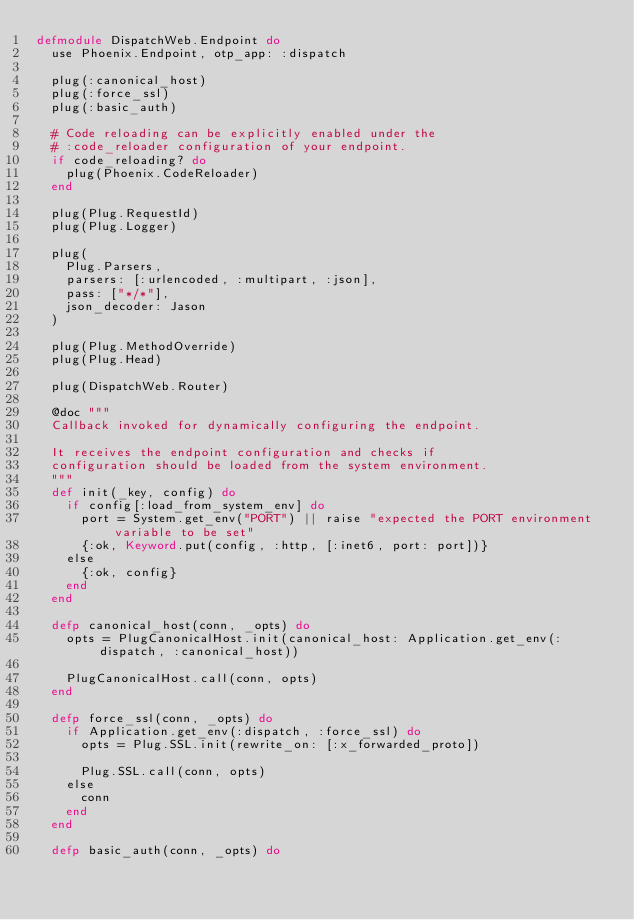Convert code to text. <code><loc_0><loc_0><loc_500><loc_500><_Elixir_>defmodule DispatchWeb.Endpoint do
  use Phoenix.Endpoint, otp_app: :dispatch

  plug(:canonical_host)
  plug(:force_ssl)
  plug(:basic_auth)

  # Code reloading can be explicitly enabled under the
  # :code_reloader configuration of your endpoint.
  if code_reloading? do
    plug(Phoenix.CodeReloader)
  end

  plug(Plug.RequestId)
  plug(Plug.Logger)

  plug(
    Plug.Parsers,
    parsers: [:urlencoded, :multipart, :json],
    pass: ["*/*"],
    json_decoder: Jason
  )

  plug(Plug.MethodOverride)
  plug(Plug.Head)

  plug(DispatchWeb.Router)

  @doc """
  Callback invoked for dynamically configuring the endpoint.

  It receives the endpoint configuration and checks if
  configuration should be loaded from the system environment.
  """
  def init(_key, config) do
    if config[:load_from_system_env] do
      port = System.get_env("PORT") || raise "expected the PORT environment variable to be set"
      {:ok, Keyword.put(config, :http, [:inet6, port: port])}
    else
      {:ok, config}
    end
  end

  defp canonical_host(conn, _opts) do
    opts = PlugCanonicalHost.init(canonical_host: Application.get_env(:dispatch, :canonical_host))

    PlugCanonicalHost.call(conn, opts)
  end

  defp force_ssl(conn, _opts) do
    if Application.get_env(:dispatch, :force_ssl) do
      opts = Plug.SSL.init(rewrite_on: [:x_forwarded_proto])

      Plug.SSL.call(conn, opts)
    else
      conn
    end
  end

  defp basic_auth(conn, _opts) do</code> 